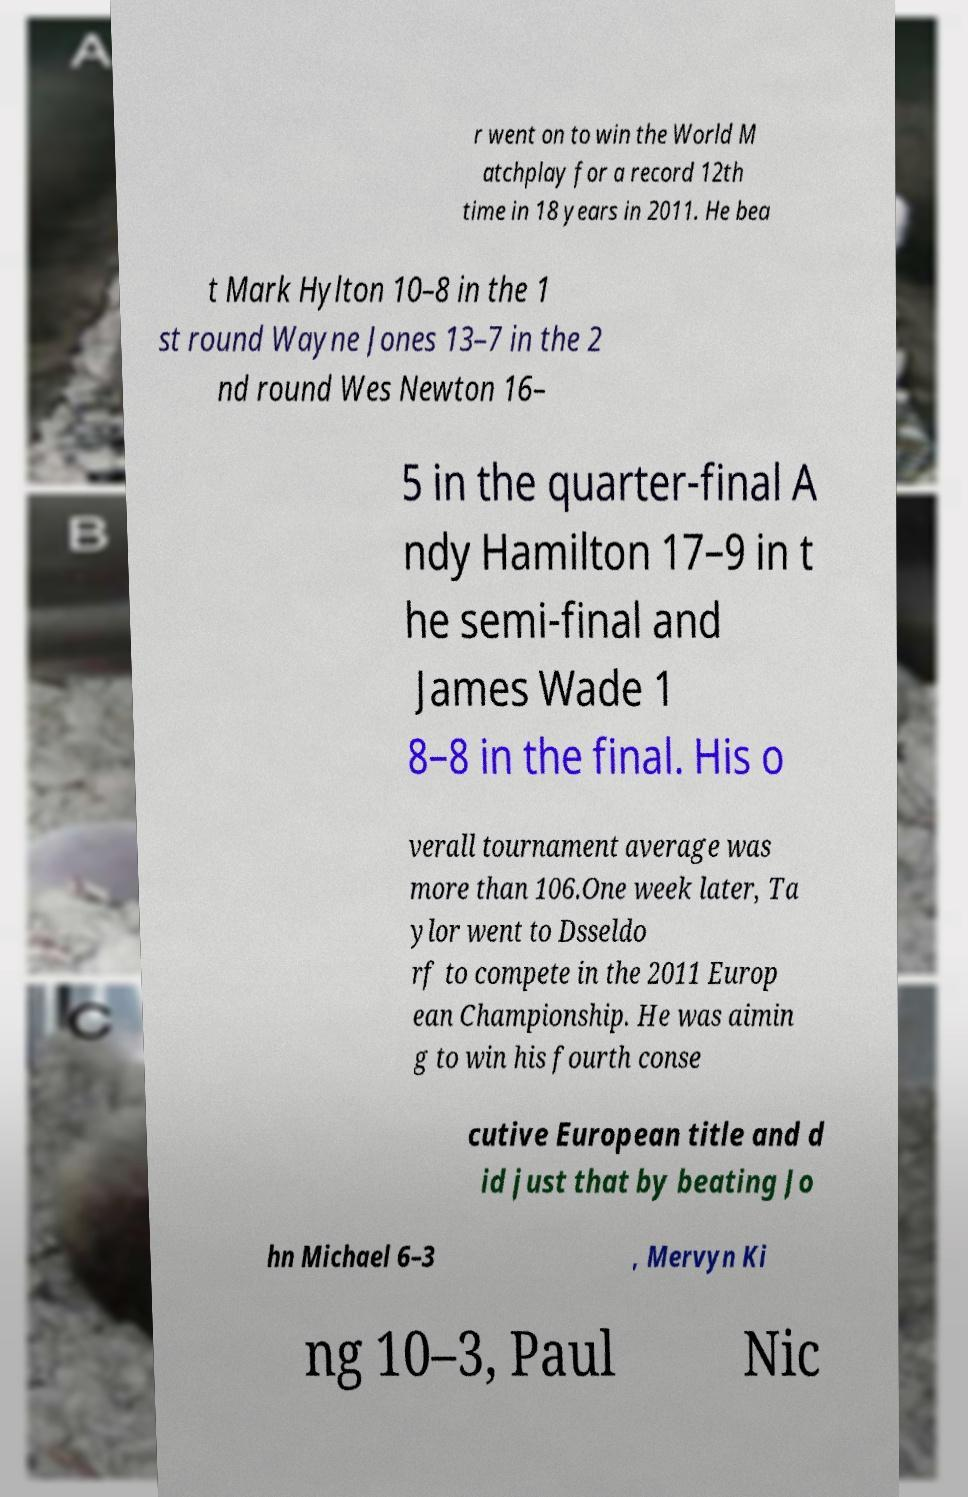Can you accurately transcribe the text from the provided image for me? r went on to win the World M atchplay for a record 12th time in 18 years in 2011. He bea t Mark Hylton 10–8 in the 1 st round Wayne Jones 13–7 in the 2 nd round Wes Newton 16– 5 in the quarter-final A ndy Hamilton 17–9 in t he semi-final and James Wade 1 8–8 in the final. His o verall tournament average was more than 106.One week later, Ta ylor went to Dsseldo rf to compete in the 2011 Europ ean Championship. He was aimin g to win his fourth conse cutive European title and d id just that by beating Jo hn Michael 6–3 , Mervyn Ki ng 10–3, Paul Nic 